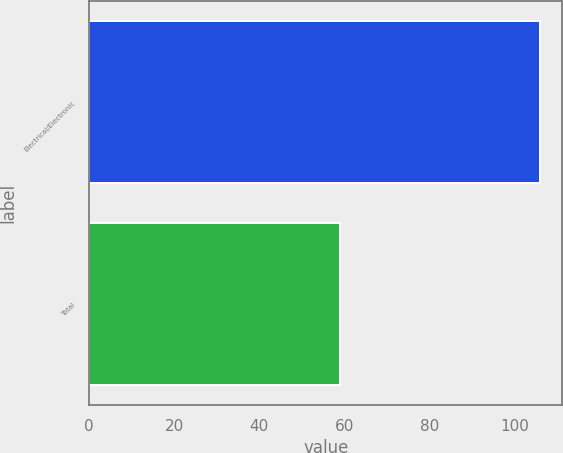Convert chart. <chart><loc_0><loc_0><loc_500><loc_500><bar_chart><fcel>Electrical/Electronic<fcel>Total<nl><fcel>106<fcel>59<nl></chart> 